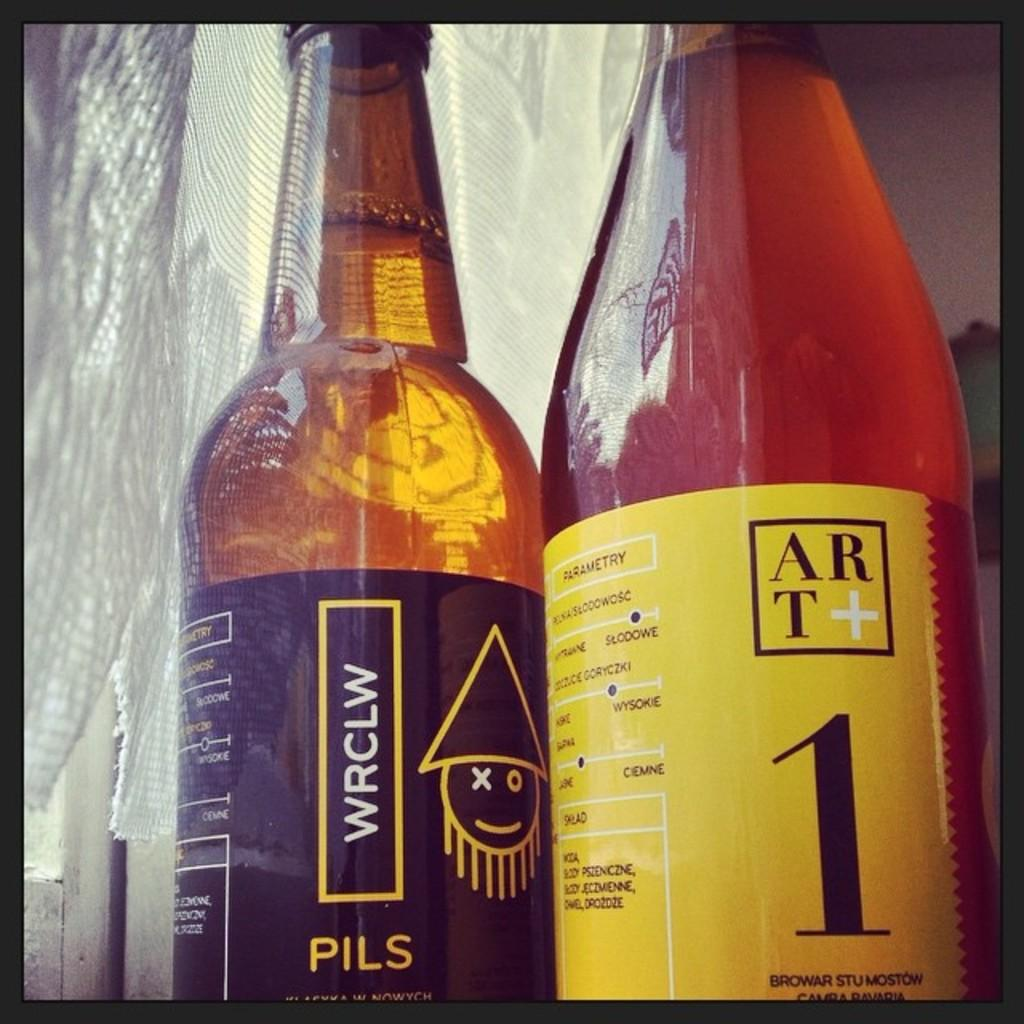<image>
Present a compact description of the photo's key features. Two beer bottles side by side, one a WRCLW Pils and the other an Art+1. 